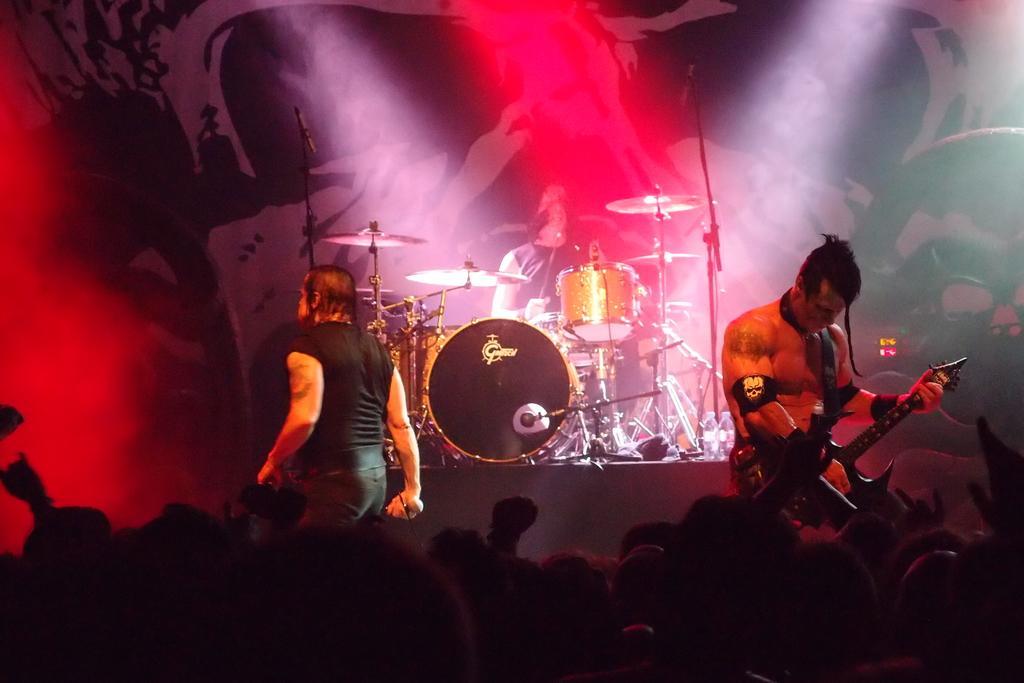Describe this image in one or two sentences. In this picture we can see some people are standing and playing a musical instrument opposite to them they are so many people sitting and looking towards the the magicians. 